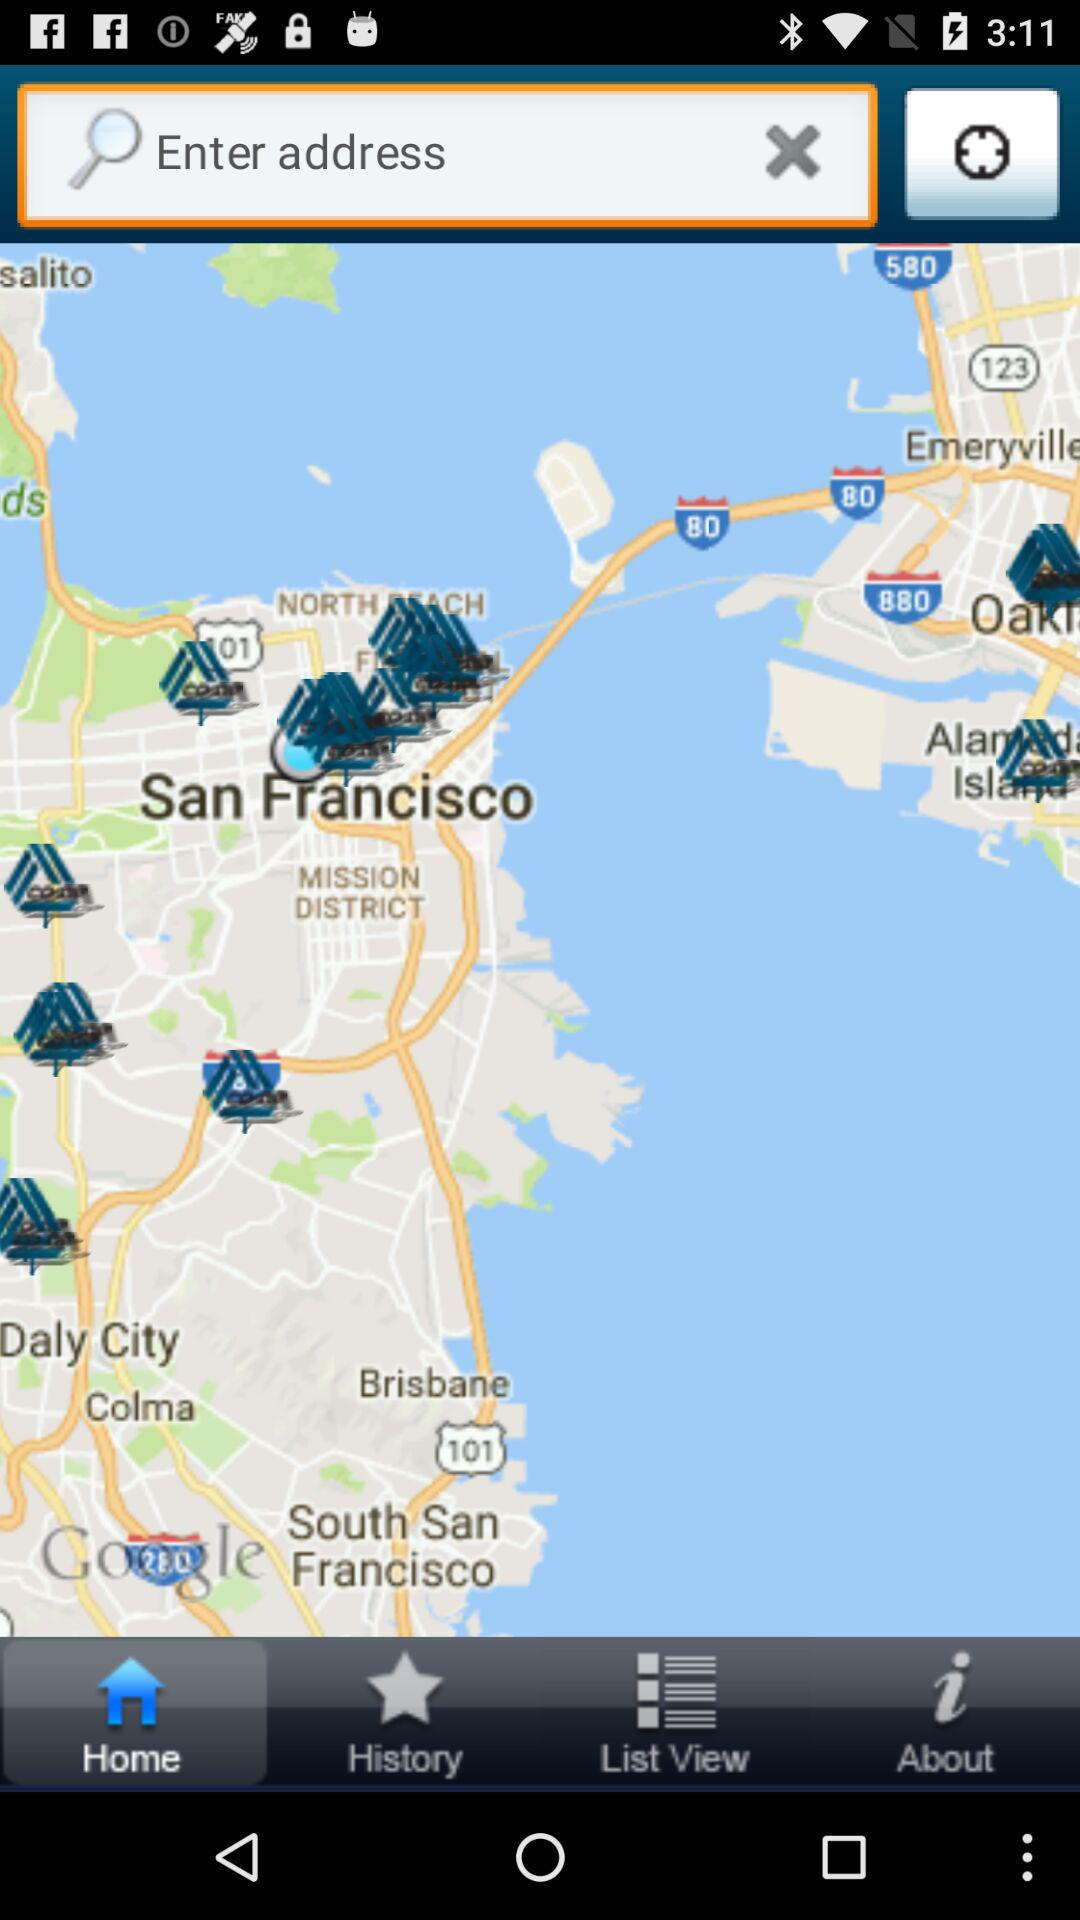Which tab is selected? Home tab is selected. 